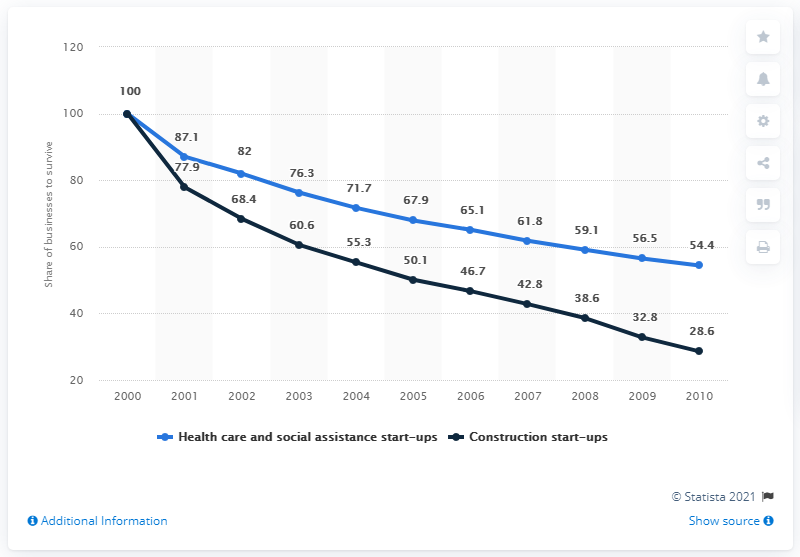In which year did the black line graph saw its highest peak?
 2000 